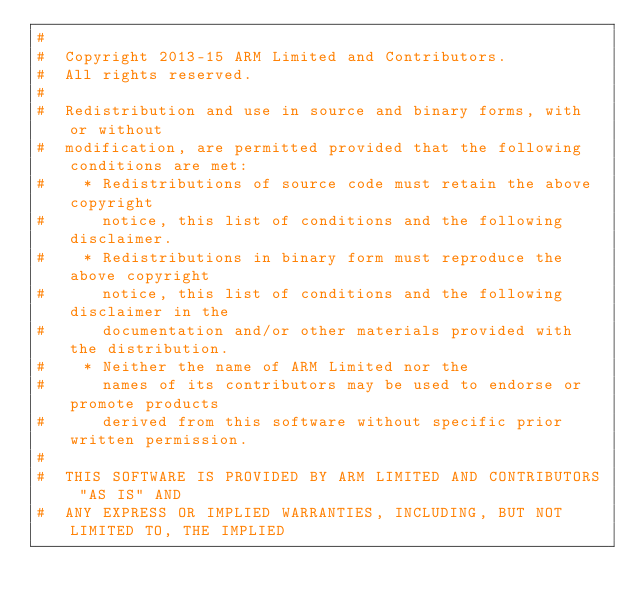<code> <loc_0><loc_0><loc_500><loc_500><_CMake_>#
#  Copyright 2013-15 ARM Limited and Contributors.
#  All rights reserved.
#
#  Redistribution and use in source and binary forms, with or without
#  modification, are permitted provided that the following conditions are met:
#    * Redistributions of source code must retain the above copyright
#      notice, this list of conditions and the following disclaimer.
#    * Redistributions in binary form must reproduce the above copyright
#      notice, this list of conditions and the following disclaimer in the
#      documentation and/or other materials provided with the distribution.
#    * Neither the name of ARM Limited nor the
#      names of its contributors may be used to endorse or promote products
#      derived from this software without specific prior written permission.
#
#  THIS SOFTWARE IS PROVIDED BY ARM LIMITED AND CONTRIBUTORS "AS IS" AND
#  ANY EXPRESS OR IMPLIED WARRANTIES, INCLUDING, BUT NOT LIMITED TO, THE IMPLIED</code> 